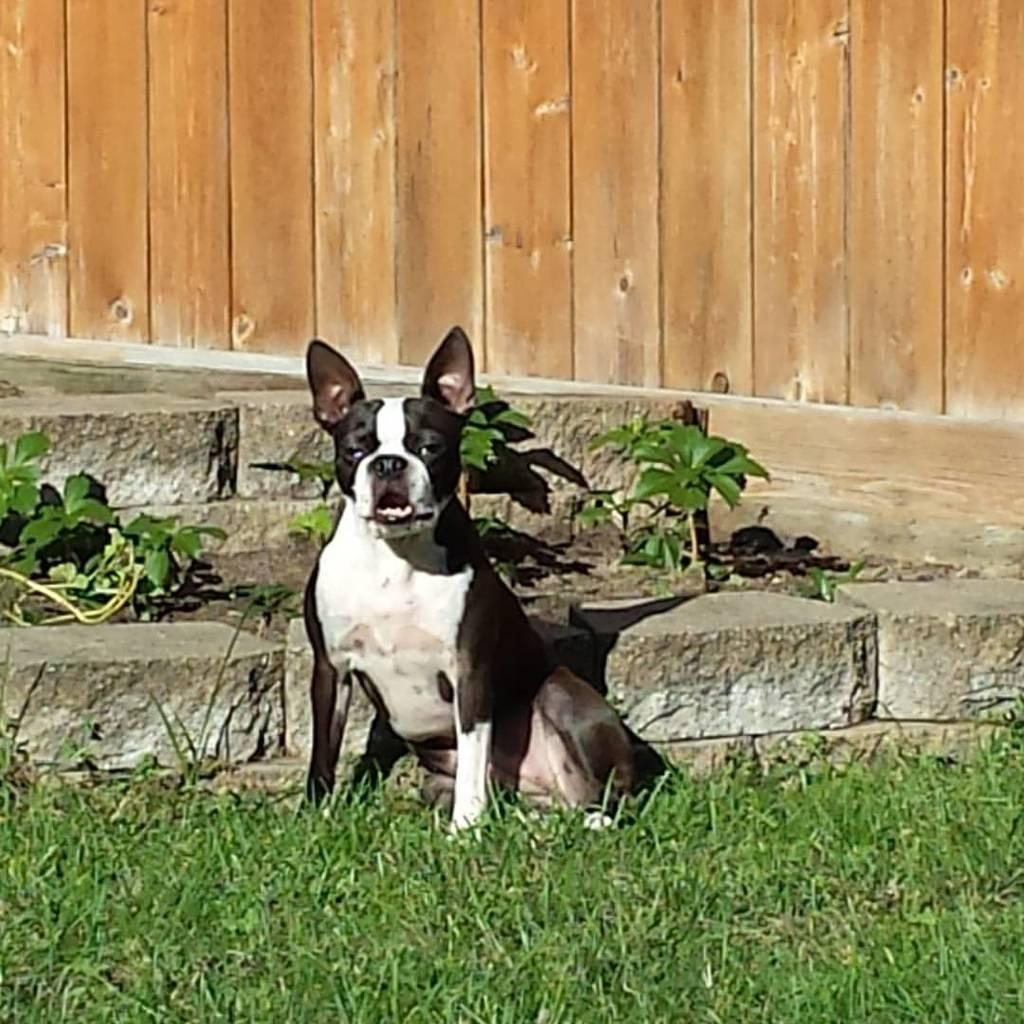What animal can be seen in the image? There is a dog in the image. Where is the dog located? The dog is sitting on the grass. What type of surface is visible behind the dog? There are stones visible behind the dog. What can be seen in the background of the image? There is a wooden wall in the background of the image. What type of arch can be seen in the image? There is no arch present in the image; it features a dog sitting on the grass with stones and a wooden wall in the background. 